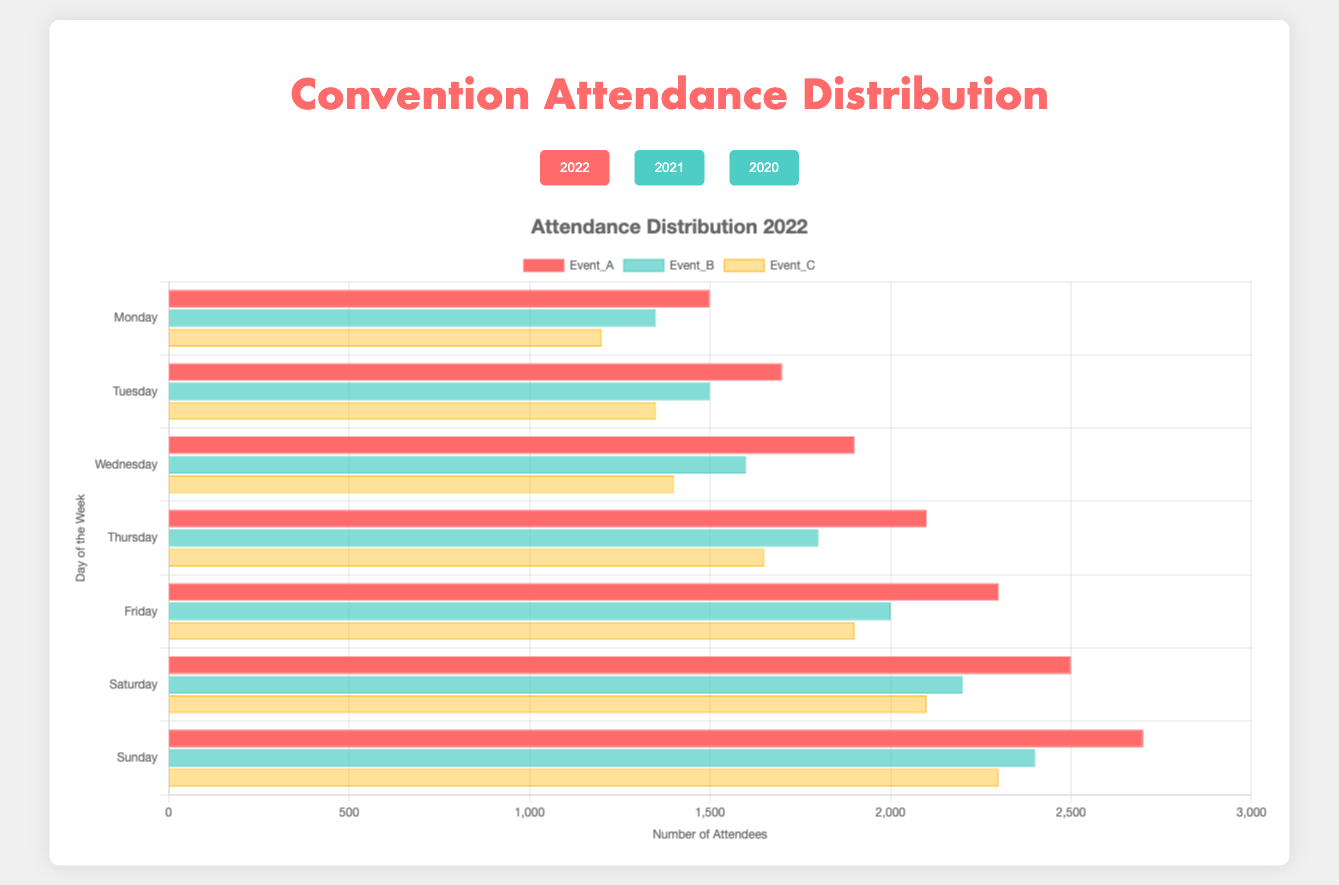How does the attendance on Monday in 2022 compare to Monday in 2021 for Event_A? The attendance for Event_A on Monday in 2022 is 1500. For 2021, it is 1400. So, 1500 (2022) is greater than 1400 (2021).
Answer: Greater Which day had the highest attendance for Event_B in 2022? From the 2022 data, the attendance for Event_B across different days is: Monday (1350), Tuesday (1500), Wednesday (1600), Thursday (1800), Friday (2000), Saturday (2200), and Sunday (2400). Sunday has the highest attendance of 2400.
Answer: Sunday What is the average attendance of Event_C over the week in 2021? For Event_C in 2021, the attendance for each day is: (1100, 1250, 1350, 1550, 1750, 1950, 2150). The total is 11100 and there are 7 days, so the average is 11100/7, which is approximately 1586.
Answer: 1586 What is the difference in attendance for Event_A on Saturday between 2022 and 2020? In 2022, Event_A's attendance on Saturday is 2500. In 2020, it is 2300. The difference is 2500 - 2300 = 200.
Answer: 200 Are the attendances of Event_C on Thursday in 2022 and 2020 equal? The attendance for Event_C on Thursday in 2022 is 1650. For 2020, it is 1450. 1650 is not equal to 1450.
Answer: No Which day showed the greatest difference in attendance for Event_B between 2022 and 2020? Calculate the attendance difference for Event_B between 2022 and 2020 for each day: Monday (1350-1200=150), Tuesday (1500-1350=150), Wednesday (1600-1450=150), Thursday (1800-1650=150), Friday (2000-1850=150), Saturday (2200-2000=200), and Sunday (2400-2200=200). Highest difference is observed on Saturday and Sunday, both 200.
Answer: Saturday and Sunday What color represents Event_C in the chart? Given the color mapping, Event_C is represented by orange color in the chart.
Answer: Orange How much did the attendance for Event_A increase from Tuesday to Wednesday in 2021? The attendance for Event_A on Tuesday in 2021 is 1600 and on Wednesday, it is 1750. The increase is 1750 - 1600 = 150.
Answer: 150 What is the total attendance for Event_B over the week in 2020? Summing the attendances of Event_B across the week in 2020: 1200 + 1350 + 1450 + 1650 + 1850 + 2000 + 2200 = 11700.
Answer: 11700 